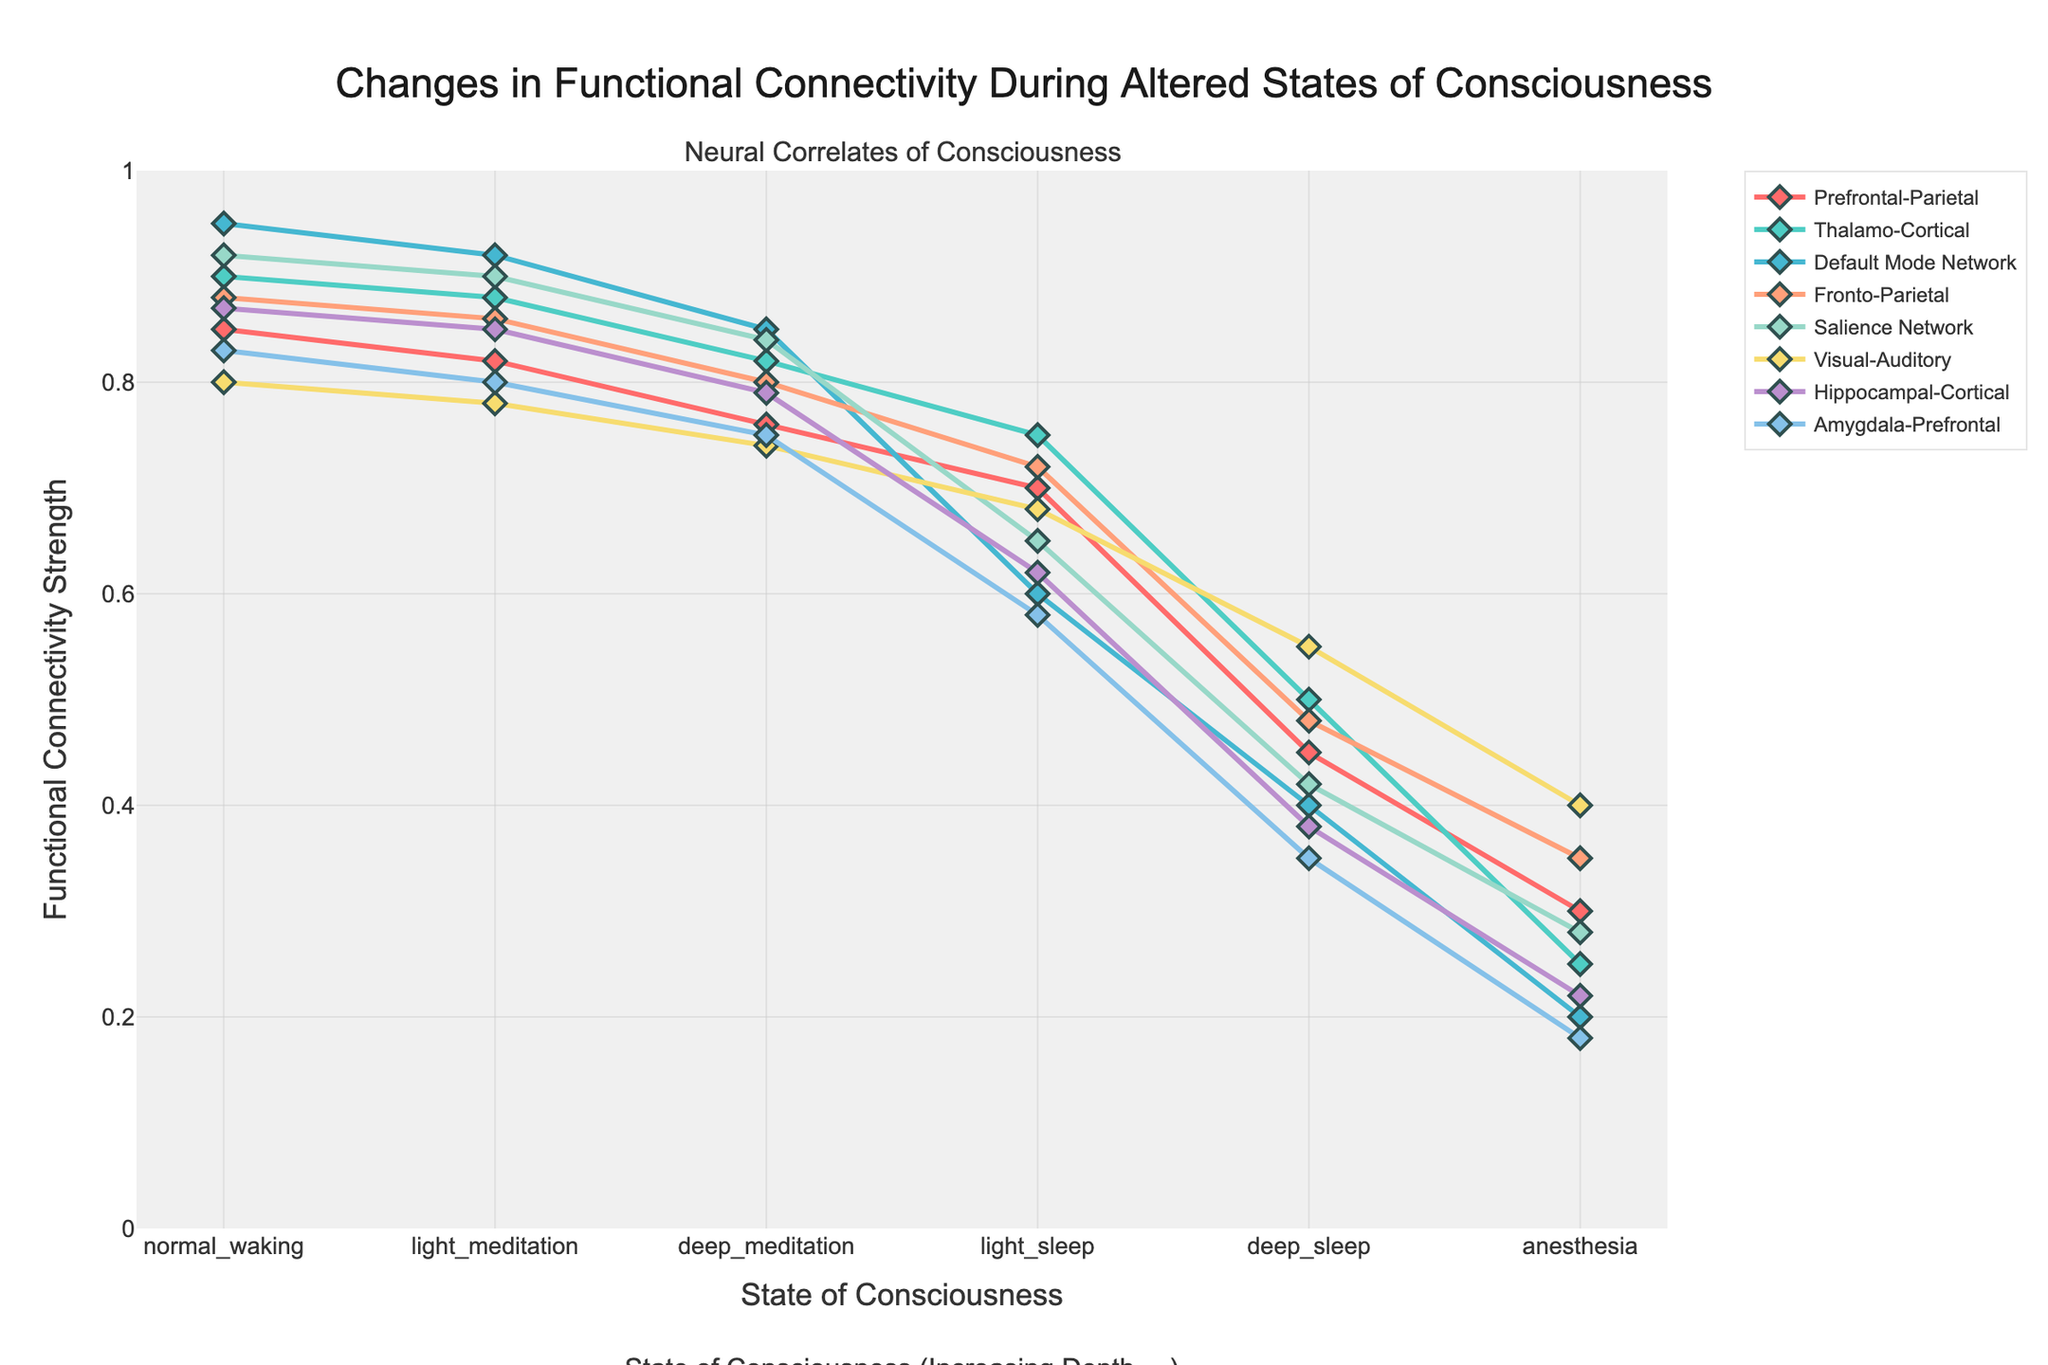Which brain area pair shows the largest decrease in functional connectivity when moving from normal waking to deep sleep? To find the largest decrease, we calculate the difference in functional connectivity between normal waking and deep sleep for each brain area pair. The largest difference is between the Default Mode Network with a decrease from 0.95 to 0.40, a difference of 0.55.
Answer: Default Mode Network Which state of consciousness shows the least variance in functional connectivity across all brain area pairs? To determine this, we look for the state with the smallest range between the minimum and maximum values of functional connectivity. Light Meditation has values between 0.78 and 0.92, which is the smallest range compared to other states.
Answer: Light Meditation What is the average functional connectivity for the Salience Network across all states of consciousness? We sum the connectivity values for the Salience Network and divide by the number of states: (0.92 + 0.90 + 0.84 + 0.65 + 0.42 + 0.28)/6 = 4.01/6 ≈ 0.67
Answer: 0.67 Which brain area pair maintains the highest connectivity under anesthesia? We look for the highest value in the column for anesthesia. The Visual-Auditory pair has the highest connectivity under anesthesia with a value of 0.40.
Answer: Visual-Auditory How does the functional connectivity of the Hippocampal-Cortical pair change from light sleep to deep sleep? We observe the values for the Hippocampal-Cortical pair in both states. The connectivity decreases from 0.62 in light sleep to 0.38 in deep sleep.
Answer: Decreases Which state of consciousness exhibits the most diverse functional connectivity values across different brain area pairs? To find this, identify the state with the largest range of values. Anesthesia has values ranging from 0.18 to 0.40, showing the greatest diversity.
Answer: Anesthesia What is the sum of the functional connectivity values for the Amygdala-Prefrontal pair in light and deep meditation? Sum the values: 0.80 (light meditation) + 0.75 (deep meditation) = 1.55
Answer: 1.55 Which brain area pair shows the highest connectivity during normal waking? The highest values for normal waking are compared, with the Default Mode Network having the highest at 0.95.
Answer: Default Mode Network How does the functional connectivity change for the Prefrontal-Parietal pair from light sleep to deep sleep? We observe the values for the Prefrontal-Parietal pair in both states. The connectivity decreases from 0.70 in light sleep to 0.45 in deep sleep.
Answer: Decreases 